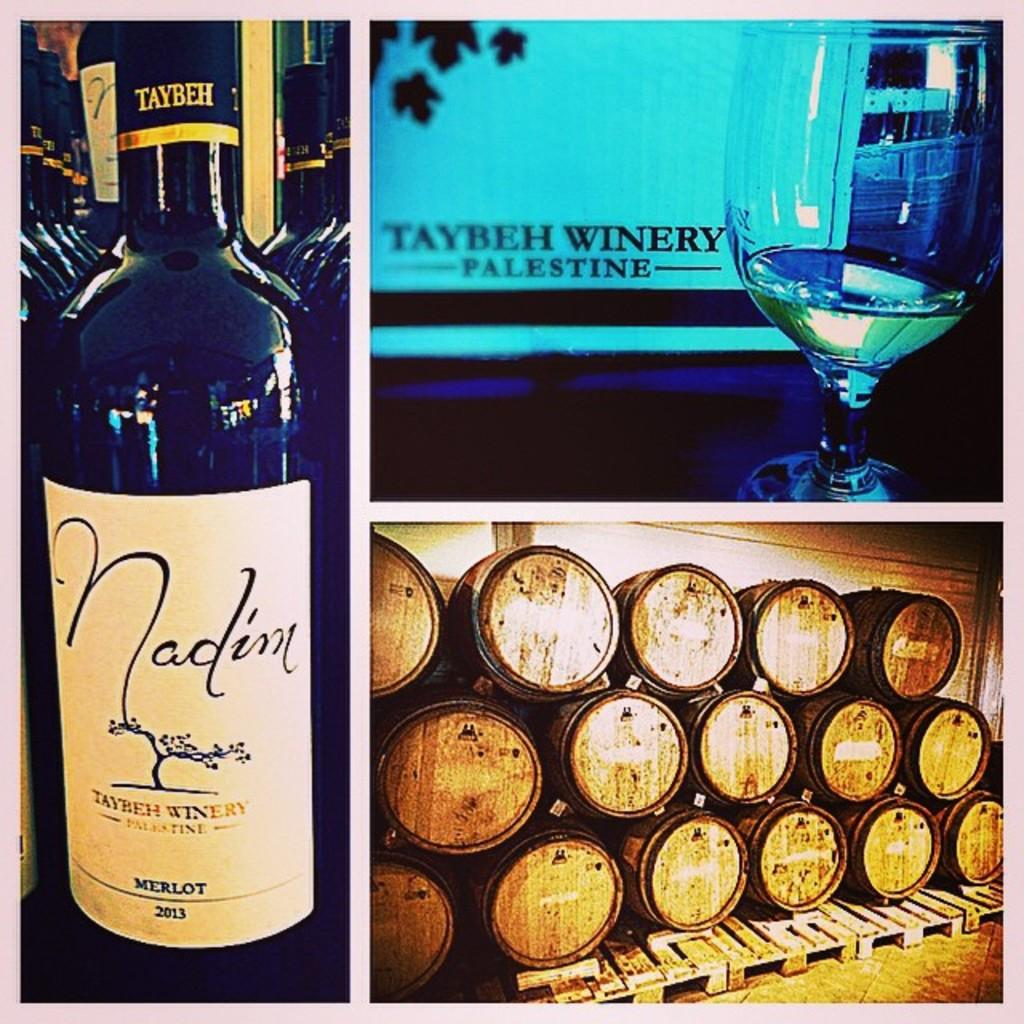<image>
Offer a succinct explanation of the picture presented. A sign for a winery that says Taybeh Winery Palestine. 